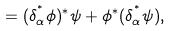<formula> <loc_0><loc_0><loc_500><loc_500>= ( \delta _ { \alpha } ^ { ^ { * } } \phi ) ^ { * } \psi + \phi ^ { * } ( \delta _ { \alpha } ^ { ^ { * } } \psi ) ,</formula> 